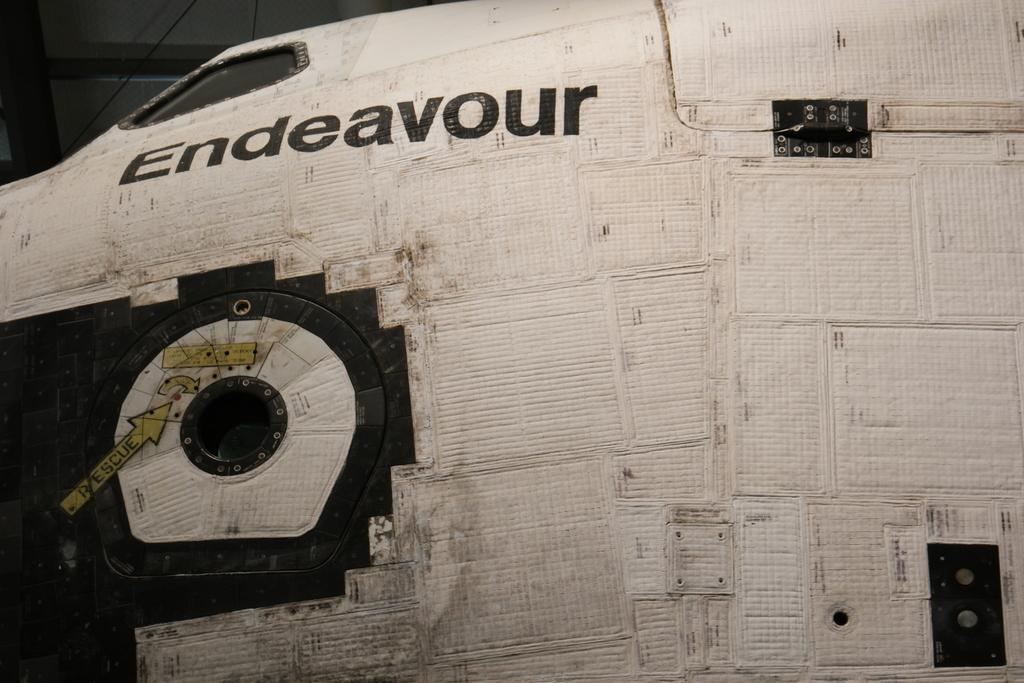Which shuttle is this?
Your answer should be very brief. Endeavour. 